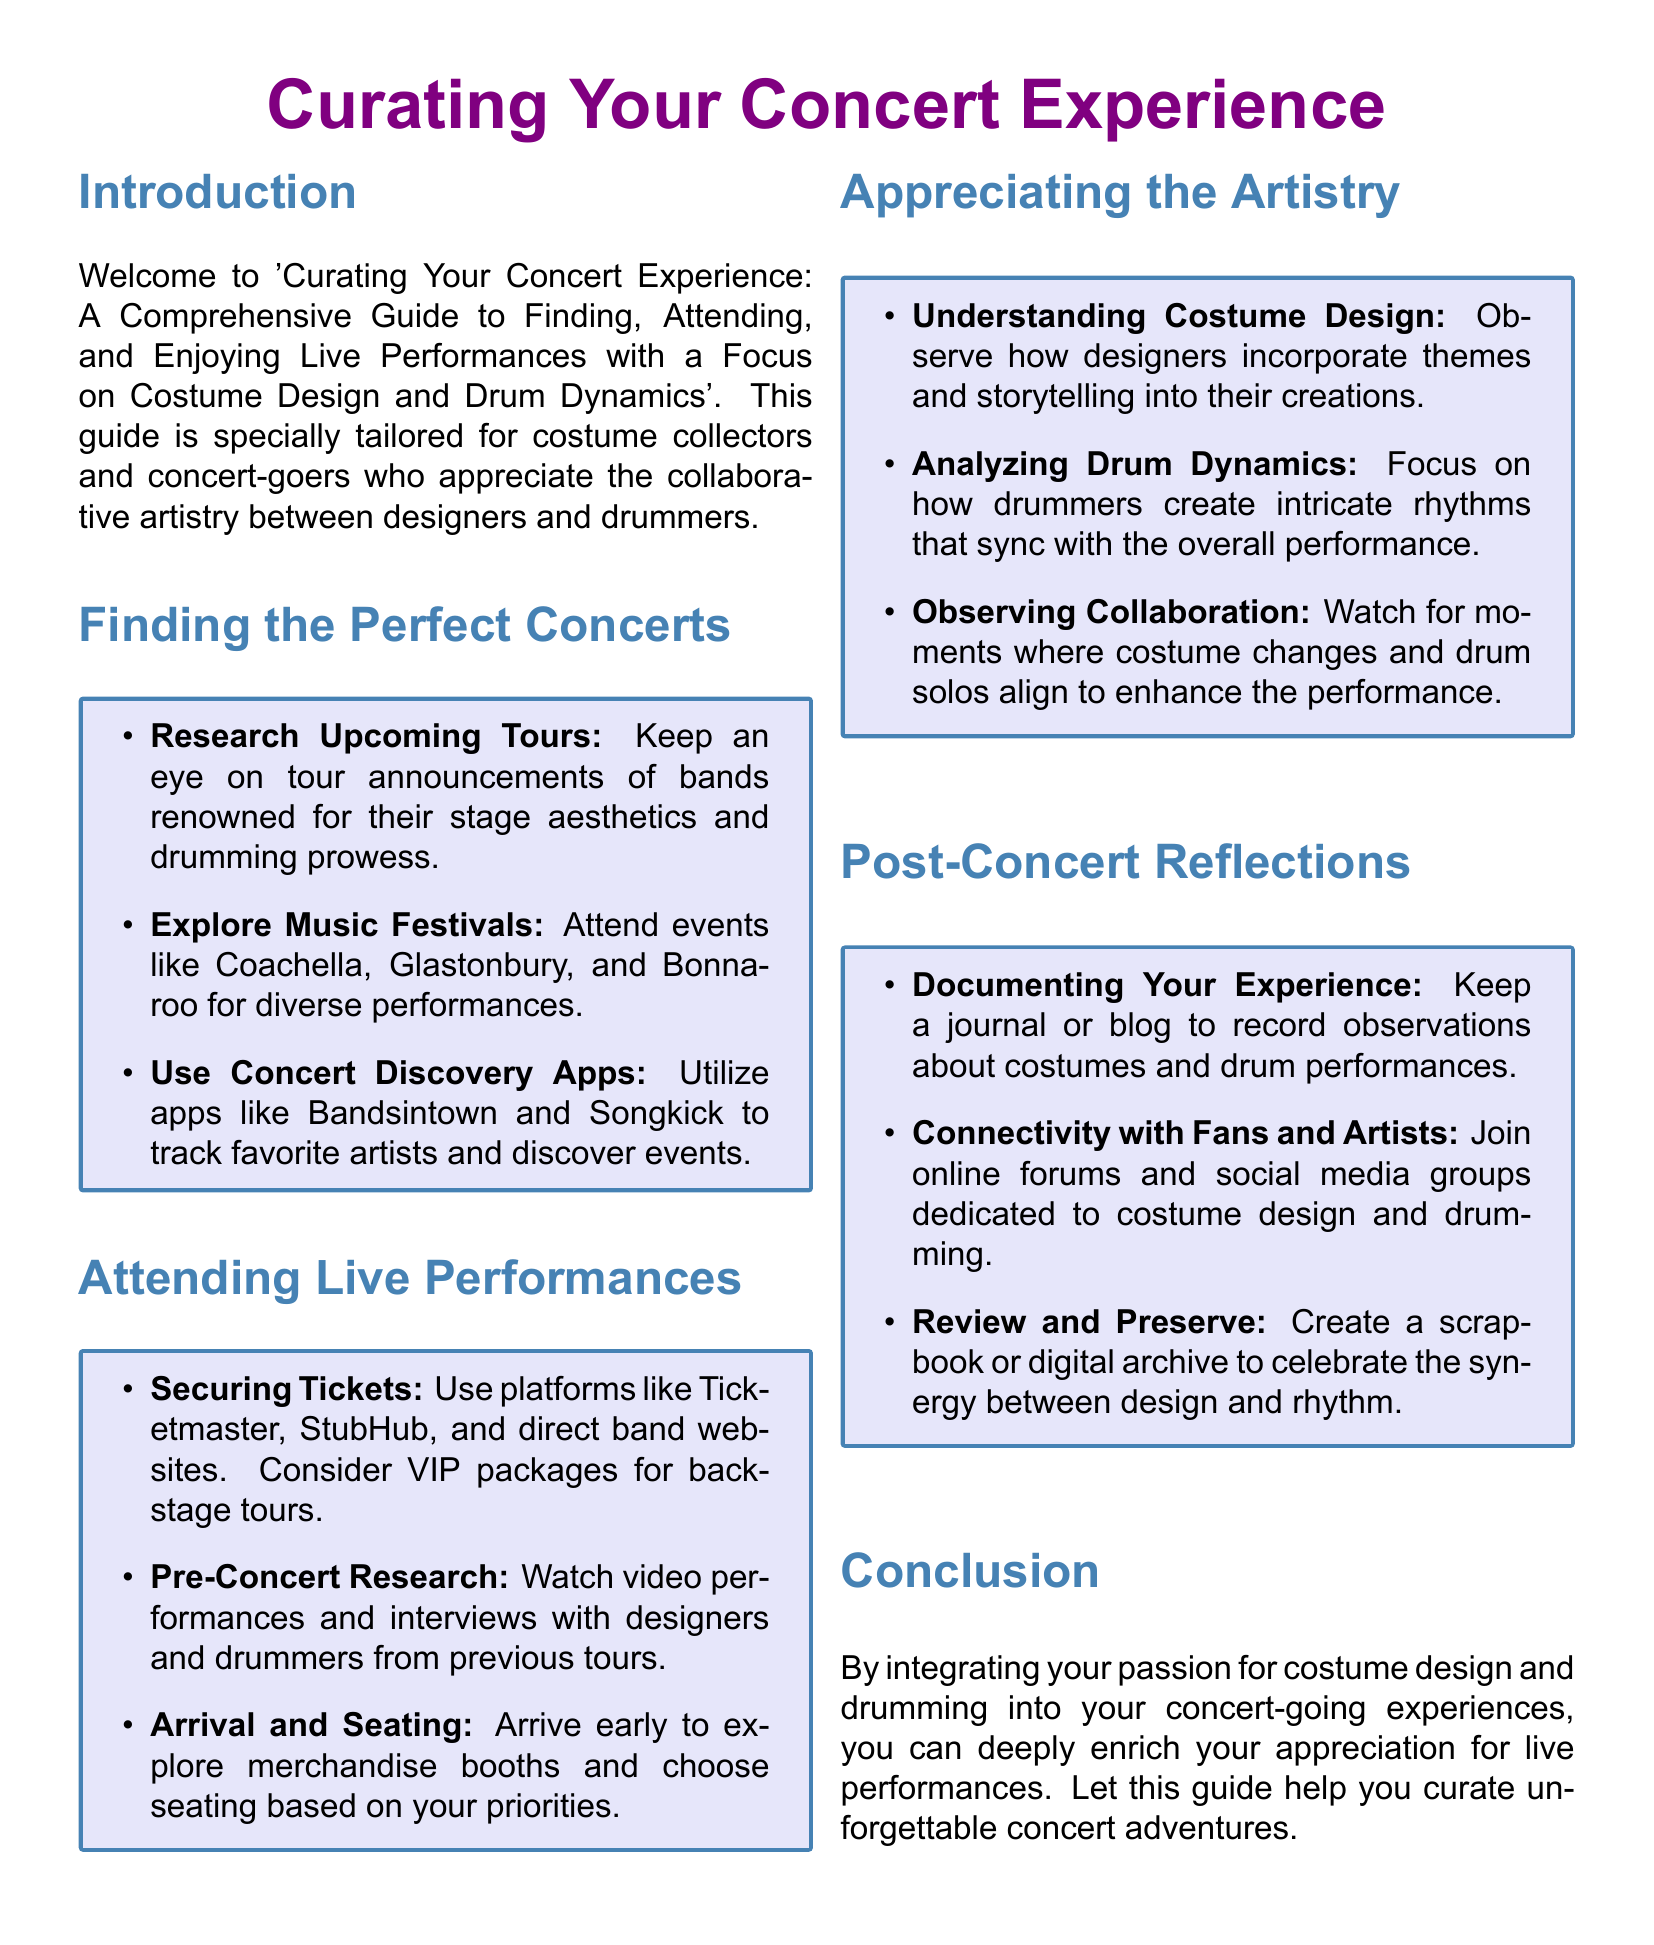What is the title of the guide? The title of the guide is prominently displayed at the top of the document as 'Curating Your Concert Experience'.
Answer: Curating Your Concert Experience What is one recommended music festival mentioned in the document? The document lists several music festivals, including Coachella, Glastonbury, and Bonnaroo, among which Coachella is one example.
Answer: Coachella Which platforms are suggested for securing concert tickets? The guide mentions several platforms for securing tickets, including Ticketmaster, StubHub, and direct band websites.
Answer: Ticketmaster What should you document after attending a concert? The guide suggests keeping a journal or blog to record observations, specifically about costumes and drum performances.
Answer: Journal What is the focus of the guide? The focus of the guide is on finding, attending, and enjoying live performances with an emphasis on costume design and drum dynamics.
Answer: Costume design and drum dynamics What does the guide recommend for pre-concert research? The document recommends watching video performances and interviews with designers and drummers from previous tours.
Answer: Video performances and interviews How can one connect with fans and artists post-concert? The guide encourages connecting with fans and artists by joining online forums and social media groups dedicated to costume design and drumming.
Answer: Online forums What should you arrive early for at a concert? Arriving early allows you to explore merchandise booths, according to the guide.
Answer: Merchandise booths What type of reflections does the guide encourage after concerts? The guide encourages post-concert reflections focused on documenting experiences and preserving memories related to costume design and drumming.
Answer: Documenting experiences 